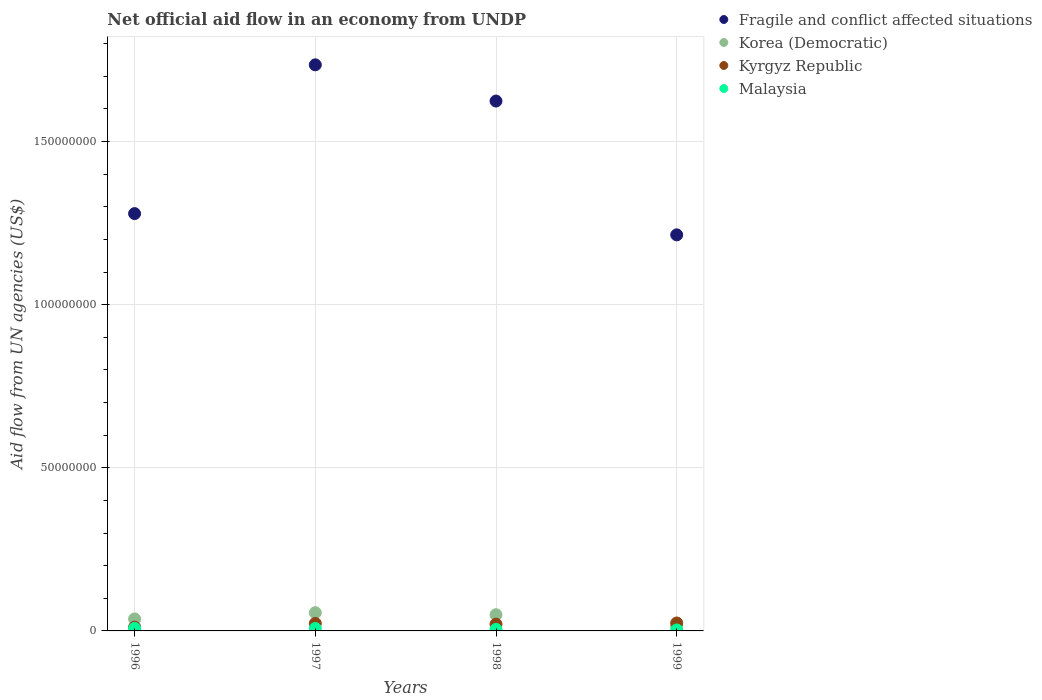How many different coloured dotlines are there?
Offer a very short reply. 4. Is the number of dotlines equal to the number of legend labels?
Make the answer very short. Yes. What is the net official aid flow in Kyrgyz Republic in 1999?
Your answer should be compact. 2.43e+06. Across all years, what is the maximum net official aid flow in Fragile and conflict affected situations?
Ensure brevity in your answer.  1.74e+08. Across all years, what is the minimum net official aid flow in Malaysia?
Provide a short and direct response. 3.00e+05. In which year was the net official aid flow in Kyrgyz Republic minimum?
Offer a terse response. 1996. What is the total net official aid flow in Korea (Democratic) in the graph?
Give a very brief answer. 1.56e+07. What is the difference between the net official aid flow in Korea (Democratic) in 1997 and that in 1998?
Give a very brief answer. 6.30e+05. What is the difference between the net official aid flow in Malaysia in 1998 and the net official aid flow in Fragile and conflict affected situations in 1996?
Offer a terse response. -1.27e+08. What is the average net official aid flow in Korea (Democratic) per year?
Your answer should be compact. 3.89e+06. In the year 1998, what is the difference between the net official aid flow in Korea (Democratic) and net official aid flow in Fragile and conflict affected situations?
Give a very brief answer. -1.57e+08. In how many years, is the net official aid flow in Kyrgyz Republic greater than 90000000 US$?
Keep it short and to the point. 0. What is the ratio of the net official aid flow in Korea (Democratic) in 1998 to that in 1999?
Ensure brevity in your answer.  3.77. What is the difference between the highest and the second highest net official aid flow in Kyrgyz Republic?
Provide a succinct answer. 1.30e+05. What is the difference between the highest and the lowest net official aid flow in Kyrgyz Republic?
Provide a succinct answer. 1.27e+06. Is the sum of the net official aid flow in Fragile and conflict affected situations in 1996 and 1998 greater than the maximum net official aid flow in Malaysia across all years?
Offer a very short reply. Yes. Is it the case that in every year, the sum of the net official aid flow in Kyrgyz Republic and net official aid flow in Fragile and conflict affected situations  is greater than the sum of net official aid flow in Malaysia and net official aid flow in Korea (Democratic)?
Your answer should be compact. No. Is it the case that in every year, the sum of the net official aid flow in Kyrgyz Republic and net official aid flow in Korea (Democratic)  is greater than the net official aid flow in Malaysia?
Keep it short and to the point. Yes. Is the net official aid flow in Fragile and conflict affected situations strictly greater than the net official aid flow in Kyrgyz Republic over the years?
Your answer should be very brief. Yes. How many dotlines are there?
Give a very brief answer. 4. Are the values on the major ticks of Y-axis written in scientific E-notation?
Offer a very short reply. No. Does the graph contain any zero values?
Offer a very short reply. No. Does the graph contain grids?
Ensure brevity in your answer.  Yes. How are the legend labels stacked?
Make the answer very short. Vertical. What is the title of the graph?
Your answer should be very brief. Net official aid flow in an economy from UNDP. What is the label or title of the Y-axis?
Provide a short and direct response. Aid flow from UN agencies (US$). What is the Aid flow from UN agencies (US$) of Fragile and conflict affected situations in 1996?
Offer a terse response. 1.28e+08. What is the Aid flow from UN agencies (US$) in Korea (Democratic) in 1996?
Provide a short and direct response. 3.68e+06. What is the Aid flow from UN agencies (US$) in Kyrgyz Republic in 1996?
Your answer should be compact. 1.16e+06. What is the Aid flow from UN agencies (US$) in Malaysia in 1996?
Ensure brevity in your answer.  7.80e+05. What is the Aid flow from UN agencies (US$) of Fragile and conflict affected situations in 1997?
Keep it short and to the point. 1.74e+08. What is the Aid flow from UN agencies (US$) in Korea (Democratic) in 1997?
Offer a terse response. 5.60e+06. What is the Aid flow from UN agencies (US$) in Kyrgyz Republic in 1997?
Keep it short and to the point. 2.30e+06. What is the Aid flow from UN agencies (US$) in Malaysia in 1997?
Give a very brief answer. 7.50e+05. What is the Aid flow from UN agencies (US$) of Fragile and conflict affected situations in 1998?
Provide a succinct answer. 1.62e+08. What is the Aid flow from UN agencies (US$) of Korea (Democratic) in 1998?
Provide a succinct answer. 4.97e+06. What is the Aid flow from UN agencies (US$) in Kyrgyz Republic in 1998?
Your answer should be compact. 2.07e+06. What is the Aid flow from UN agencies (US$) in Fragile and conflict affected situations in 1999?
Your answer should be very brief. 1.21e+08. What is the Aid flow from UN agencies (US$) in Korea (Democratic) in 1999?
Your response must be concise. 1.32e+06. What is the Aid flow from UN agencies (US$) of Kyrgyz Republic in 1999?
Keep it short and to the point. 2.43e+06. Across all years, what is the maximum Aid flow from UN agencies (US$) in Fragile and conflict affected situations?
Offer a very short reply. 1.74e+08. Across all years, what is the maximum Aid flow from UN agencies (US$) in Korea (Democratic)?
Provide a short and direct response. 5.60e+06. Across all years, what is the maximum Aid flow from UN agencies (US$) in Kyrgyz Republic?
Your answer should be very brief. 2.43e+06. Across all years, what is the maximum Aid flow from UN agencies (US$) in Malaysia?
Ensure brevity in your answer.  7.80e+05. Across all years, what is the minimum Aid flow from UN agencies (US$) in Fragile and conflict affected situations?
Give a very brief answer. 1.21e+08. Across all years, what is the minimum Aid flow from UN agencies (US$) of Korea (Democratic)?
Your answer should be compact. 1.32e+06. Across all years, what is the minimum Aid flow from UN agencies (US$) of Kyrgyz Republic?
Offer a terse response. 1.16e+06. Across all years, what is the minimum Aid flow from UN agencies (US$) in Malaysia?
Your answer should be compact. 3.00e+05. What is the total Aid flow from UN agencies (US$) in Fragile and conflict affected situations in the graph?
Keep it short and to the point. 5.85e+08. What is the total Aid flow from UN agencies (US$) in Korea (Democratic) in the graph?
Offer a very short reply. 1.56e+07. What is the total Aid flow from UN agencies (US$) in Kyrgyz Republic in the graph?
Give a very brief answer. 7.96e+06. What is the total Aid flow from UN agencies (US$) in Malaysia in the graph?
Provide a short and direct response. 2.29e+06. What is the difference between the Aid flow from UN agencies (US$) in Fragile and conflict affected situations in 1996 and that in 1997?
Give a very brief answer. -4.56e+07. What is the difference between the Aid flow from UN agencies (US$) in Korea (Democratic) in 1996 and that in 1997?
Offer a terse response. -1.92e+06. What is the difference between the Aid flow from UN agencies (US$) in Kyrgyz Republic in 1996 and that in 1997?
Provide a succinct answer. -1.14e+06. What is the difference between the Aid flow from UN agencies (US$) in Malaysia in 1996 and that in 1997?
Keep it short and to the point. 3.00e+04. What is the difference between the Aid flow from UN agencies (US$) of Fragile and conflict affected situations in 1996 and that in 1998?
Provide a short and direct response. -3.45e+07. What is the difference between the Aid flow from UN agencies (US$) in Korea (Democratic) in 1996 and that in 1998?
Ensure brevity in your answer.  -1.29e+06. What is the difference between the Aid flow from UN agencies (US$) in Kyrgyz Republic in 1996 and that in 1998?
Keep it short and to the point. -9.10e+05. What is the difference between the Aid flow from UN agencies (US$) of Fragile and conflict affected situations in 1996 and that in 1999?
Your answer should be very brief. 6.51e+06. What is the difference between the Aid flow from UN agencies (US$) in Korea (Democratic) in 1996 and that in 1999?
Provide a short and direct response. 2.36e+06. What is the difference between the Aid flow from UN agencies (US$) in Kyrgyz Republic in 1996 and that in 1999?
Your answer should be compact. -1.27e+06. What is the difference between the Aid flow from UN agencies (US$) in Fragile and conflict affected situations in 1997 and that in 1998?
Your answer should be compact. 1.11e+07. What is the difference between the Aid flow from UN agencies (US$) of Korea (Democratic) in 1997 and that in 1998?
Ensure brevity in your answer.  6.30e+05. What is the difference between the Aid flow from UN agencies (US$) in Kyrgyz Republic in 1997 and that in 1998?
Ensure brevity in your answer.  2.30e+05. What is the difference between the Aid flow from UN agencies (US$) of Malaysia in 1997 and that in 1998?
Offer a very short reply. 2.90e+05. What is the difference between the Aid flow from UN agencies (US$) in Fragile and conflict affected situations in 1997 and that in 1999?
Offer a very short reply. 5.21e+07. What is the difference between the Aid flow from UN agencies (US$) in Korea (Democratic) in 1997 and that in 1999?
Make the answer very short. 4.28e+06. What is the difference between the Aid flow from UN agencies (US$) in Kyrgyz Republic in 1997 and that in 1999?
Make the answer very short. -1.30e+05. What is the difference between the Aid flow from UN agencies (US$) in Fragile and conflict affected situations in 1998 and that in 1999?
Provide a short and direct response. 4.10e+07. What is the difference between the Aid flow from UN agencies (US$) of Korea (Democratic) in 1998 and that in 1999?
Give a very brief answer. 3.65e+06. What is the difference between the Aid flow from UN agencies (US$) in Kyrgyz Republic in 1998 and that in 1999?
Keep it short and to the point. -3.60e+05. What is the difference between the Aid flow from UN agencies (US$) in Malaysia in 1998 and that in 1999?
Your answer should be very brief. 1.60e+05. What is the difference between the Aid flow from UN agencies (US$) of Fragile and conflict affected situations in 1996 and the Aid flow from UN agencies (US$) of Korea (Democratic) in 1997?
Give a very brief answer. 1.22e+08. What is the difference between the Aid flow from UN agencies (US$) of Fragile and conflict affected situations in 1996 and the Aid flow from UN agencies (US$) of Kyrgyz Republic in 1997?
Ensure brevity in your answer.  1.26e+08. What is the difference between the Aid flow from UN agencies (US$) in Fragile and conflict affected situations in 1996 and the Aid flow from UN agencies (US$) in Malaysia in 1997?
Ensure brevity in your answer.  1.27e+08. What is the difference between the Aid flow from UN agencies (US$) of Korea (Democratic) in 1996 and the Aid flow from UN agencies (US$) of Kyrgyz Republic in 1997?
Provide a succinct answer. 1.38e+06. What is the difference between the Aid flow from UN agencies (US$) in Korea (Democratic) in 1996 and the Aid flow from UN agencies (US$) in Malaysia in 1997?
Keep it short and to the point. 2.93e+06. What is the difference between the Aid flow from UN agencies (US$) in Fragile and conflict affected situations in 1996 and the Aid flow from UN agencies (US$) in Korea (Democratic) in 1998?
Your answer should be compact. 1.23e+08. What is the difference between the Aid flow from UN agencies (US$) in Fragile and conflict affected situations in 1996 and the Aid flow from UN agencies (US$) in Kyrgyz Republic in 1998?
Provide a short and direct response. 1.26e+08. What is the difference between the Aid flow from UN agencies (US$) of Fragile and conflict affected situations in 1996 and the Aid flow from UN agencies (US$) of Malaysia in 1998?
Your answer should be very brief. 1.27e+08. What is the difference between the Aid flow from UN agencies (US$) of Korea (Democratic) in 1996 and the Aid flow from UN agencies (US$) of Kyrgyz Republic in 1998?
Provide a short and direct response. 1.61e+06. What is the difference between the Aid flow from UN agencies (US$) in Korea (Democratic) in 1996 and the Aid flow from UN agencies (US$) in Malaysia in 1998?
Provide a short and direct response. 3.22e+06. What is the difference between the Aid flow from UN agencies (US$) of Fragile and conflict affected situations in 1996 and the Aid flow from UN agencies (US$) of Korea (Democratic) in 1999?
Provide a succinct answer. 1.27e+08. What is the difference between the Aid flow from UN agencies (US$) of Fragile and conflict affected situations in 1996 and the Aid flow from UN agencies (US$) of Kyrgyz Republic in 1999?
Give a very brief answer. 1.25e+08. What is the difference between the Aid flow from UN agencies (US$) in Fragile and conflict affected situations in 1996 and the Aid flow from UN agencies (US$) in Malaysia in 1999?
Your response must be concise. 1.28e+08. What is the difference between the Aid flow from UN agencies (US$) in Korea (Democratic) in 1996 and the Aid flow from UN agencies (US$) in Kyrgyz Republic in 1999?
Provide a short and direct response. 1.25e+06. What is the difference between the Aid flow from UN agencies (US$) in Korea (Democratic) in 1996 and the Aid flow from UN agencies (US$) in Malaysia in 1999?
Your response must be concise. 3.38e+06. What is the difference between the Aid flow from UN agencies (US$) of Kyrgyz Republic in 1996 and the Aid flow from UN agencies (US$) of Malaysia in 1999?
Ensure brevity in your answer.  8.60e+05. What is the difference between the Aid flow from UN agencies (US$) of Fragile and conflict affected situations in 1997 and the Aid flow from UN agencies (US$) of Korea (Democratic) in 1998?
Ensure brevity in your answer.  1.69e+08. What is the difference between the Aid flow from UN agencies (US$) in Fragile and conflict affected situations in 1997 and the Aid flow from UN agencies (US$) in Kyrgyz Republic in 1998?
Your response must be concise. 1.71e+08. What is the difference between the Aid flow from UN agencies (US$) in Fragile and conflict affected situations in 1997 and the Aid flow from UN agencies (US$) in Malaysia in 1998?
Keep it short and to the point. 1.73e+08. What is the difference between the Aid flow from UN agencies (US$) in Korea (Democratic) in 1997 and the Aid flow from UN agencies (US$) in Kyrgyz Republic in 1998?
Provide a succinct answer. 3.53e+06. What is the difference between the Aid flow from UN agencies (US$) in Korea (Democratic) in 1997 and the Aid flow from UN agencies (US$) in Malaysia in 1998?
Make the answer very short. 5.14e+06. What is the difference between the Aid flow from UN agencies (US$) in Kyrgyz Republic in 1997 and the Aid flow from UN agencies (US$) in Malaysia in 1998?
Offer a terse response. 1.84e+06. What is the difference between the Aid flow from UN agencies (US$) of Fragile and conflict affected situations in 1997 and the Aid flow from UN agencies (US$) of Korea (Democratic) in 1999?
Make the answer very short. 1.72e+08. What is the difference between the Aid flow from UN agencies (US$) of Fragile and conflict affected situations in 1997 and the Aid flow from UN agencies (US$) of Kyrgyz Republic in 1999?
Provide a short and direct response. 1.71e+08. What is the difference between the Aid flow from UN agencies (US$) of Fragile and conflict affected situations in 1997 and the Aid flow from UN agencies (US$) of Malaysia in 1999?
Give a very brief answer. 1.73e+08. What is the difference between the Aid flow from UN agencies (US$) in Korea (Democratic) in 1997 and the Aid flow from UN agencies (US$) in Kyrgyz Republic in 1999?
Provide a short and direct response. 3.17e+06. What is the difference between the Aid flow from UN agencies (US$) of Korea (Democratic) in 1997 and the Aid flow from UN agencies (US$) of Malaysia in 1999?
Keep it short and to the point. 5.30e+06. What is the difference between the Aid flow from UN agencies (US$) in Kyrgyz Republic in 1997 and the Aid flow from UN agencies (US$) in Malaysia in 1999?
Give a very brief answer. 2.00e+06. What is the difference between the Aid flow from UN agencies (US$) of Fragile and conflict affected situations in 1998 and the Aid flow from UN agencies (US$) of Korea (Democratic) in 1999?
Ensure brevity in your answer.  1.61e+08. What is the difference between the Aid flow from UN agencies (US$) in Fragile and conflict affected situations in 1998 and the Aid flow from UN agencies (US$) in Kyrgyz Republic in 1999?
Offer a terse response. 1.60e+08. What is the difference between the Aid flow from UN agencies (US$) in Fragile and conflict affected situations in 1998 and the Aid flow from UN agencies (US$) in Malaysia in 1999?
Make the answer very short. 1.62e+08. What is the difference between the Aid flow from UN agencies (US$) of Korea (Democratic) in 1998 and the Aid flow from UN agencies (US$) of Kyrgyz Republic in 1999?
Your answer should be very brief. 2.54e+06. What is the difference between the Aid flow from UN agencies (US$) in Korea (Democratic) in 1998 and the Aid flow from UN agencies (US$) in Malaysia in 1999?
Offer a terse response. 4.67e+06. What is the difference between the Aid flow from UN agencies (US$) in Kyrgyz Republic in 1998 and the Aid flow from UN agencies (US$) in Malaysia in 1999?
Ensure brevity in your answer.  1.77e+06. What is the average Aid flow from UN agencies (US$) in Fragile and conflict affected situations per year?
Provide a succinct answer. 1.46e+08. What is the average Aid flow from UN agencies (US$) of Korea (Democratic) per year?
Ensure brevity in your answer.  3.89e+06. What is the average Aid flow from UN agencies (US$) of Kyrgyz Republic per year?
Your response must be concise. 1.99e+06. What is the average Aid flow from UN agencies (US$) in Malaysia per year?
Offer a very short reply. 5.72e+05. In the year 1996, what is the difference between the Aid flow from UN agencies (US$) in Fragile and conflict affected situations and Aid flow from UN agencies (US$) in Korea (Democratic)?
Ensure brevity in your answer.  1.24e+08. In the year 1996, what is the difference between the Aid flow from UN agencies (US$) in Fragile and conflict affected situations and Aid flow from UN agencies (US$) in Kyrgyz Republic?
Your answer should be compact. 1.27e+08. In the year 1996, what is the difference between the Aid flow from UN agencies (US$) of Fragile and conflict affected situations and Aid flow from UN agencies (US$) of Malaysia?
Your answer should be very brief. 1.27e+08. In the year 1996, what is the difference between the Aid flow from UN agencies (US$) in Korea (Democratic) and Aid flow from UN agencies (US$) in Kyrgyz Republic?
Provide a succinct answer. 2.52e+06. In the year 1996, what is the difference between the Aid flow from UN agencies (US$) in Korea (Democratic) and Aid flow from UN agencies (US$) in Malaysia?
Keep it short and to the point. 2.90e+06. In the year 1996, what is the difference between the Aid flow from UN agencies (US$) in Kyrgyz Republic and Aid flow from UN agencies (US$) in Malaysia?
Your answer should be compact. 3.80e+05. In the year 1997, what is the difference between the Aid flow from UN agencies (US$) in Fragile and conflict affected situations and Aid flow from UN agencies (US$) in Korea (Democratic)?
Make the answer very short. 1.68e+08. In the year 1997, what is the difference between the Aid flow from UN agencies (US$) of Fragile and conflict affected situations and Aid flow from UN agencies (US$) of Kyrgyz Republic?
Give a very brief answer. 1.71e+08. In the year 1997, what is the difference between the Aid flow from UN agencies (US$) of Fragile and conflict affected situations and Aid flow from UN agencies (US$) of Malaysia?
Your answer should be very brief. 1.73e+08. In the year 1997, what is the difference between the Aid flow from UN agencies (US$) in Korea (Democratic) and Aid flow from UN agencies (US$) in Kyrgyz Republic?
Provide a succinct answer. 3.30e+06. In the year 1997, what is the difference between the Aid flow from UN agencies (US$) in Korea (Democratic) and Aid flow from UN agencies (US$) in Malaysia?
Your answer should be very brief. 4.85e+06. In the year 1997, what is the difference between the Aid flow from UN agencies (US$) of Kyrgyz Republic and Aid flow from UN agencies (US$) of Malaysia?
Ensure brevity in your answer.  1.55e+06. In the year 1998, what is the difference between the Aid flow from UN agencies (US$) in Fragile and conflict affected situations and Aid flow from UN agencies (US$) in Korea (Democratic)?
Offer a very short reply. 1.57e+08. In the year 1998, what is the difference between the Aid flow from UN agencies (US$) in Fragile and conflict affected situations and Aid flow from UN agencies (US$) in Kyrgyz Republic?
Keep it short and to the point. 1.60e+08. In the year 1998, what is the difference between the Aid flow from UN agencies (US$) of Fragile and conflict affected situations and Aid flow from UN agencies (US$) of Malaysia?
Provide a succinct answer. 1.62e+08. In the year 1998, what is the difference between the Aid flow from UN agencies (US$) in Korea (Democratic) and Aid flow from UN agencies (US$) in Kyrgyz Republic?
Provide a short and direct response. 2.90e+06. In the year 1998, what is the difference between the Aid flow from UN agencies (US$) in Korea (Democratic) and Aid flow from UN agencies (US$) in Malaysia?
Keep it short and to the point. 4.51e+06. In the year 1998, what is the difference between the Aid flow from UN agencies (US$) of Kyrgyz Republic and Aid flow from UN agencies (US$) of Malaysia?
Your answer should be very brief. 1.61e+06. In the year 1999, what is the difference between the Aid flow from UN agencies (US$) of Fragile and conflict affected situations and Aid flow from UN agencies (US$) of Korea (Democratic)?
Keep it short and to the point. 1.20e+08. In the year 1999, what is the difference between the Aid flow from UN agencies (US$) in Fragile and conflict affected situations and Aid flow from UN agencies (US$) in Kyrgyz Republic?
Ensure brevity in your answer.  1.19e+08. In the year 1999, what is the difference between the Aid flow from UN agencies (US$) of Fragile and conflict affected situations and Aid flow from UN agencies (US$) of Malaysia?
Offer a very short reply. 1.21e+08. In the year 1999, what is the difference between the Aid flow from UN agencies (US$) of Korea (Democratic) and Aid flow from UN agencies (US$) of Kyrgyz Republic?
Your answer should be compact. -1.11e+06. In the year 1999, what is the difference between the Aid flow from UN agencies (US$) of Korea (Democratic) and Aid flow from UN agencies (US$) of Malaysia?
Offer a terse response. 1.02e+06. In the year 1999, what is the difference between the Aid flow from UN agencies (US$) of Kyrgyz Republic and Aid flow from UN agencies (US$) of Malaysia?
Make the answer very short. 2.13e+06. What is the ratio of the Aid flow from UN agencies (US$) of Fragile and conflict affected situations in 1996 to that in 1997?
Provide a succinct answer. 0.74. What is the ratio of the Aid flow from UN agencies (US$) in Korea (Democratic) in 1996 to that in 1997?
Provide a succinct answer. 0.66. What is the ratio of the Aid flow from UN agencies (US$) in Kyrgyz Republic in 1996 to that in 1997?
Give a very brief answer. 0.5. What is the ratio of the Aid flow from UN agencies (US$) in Fragile and conflict affected situations in 1996 to that in 1998?
Provide a short and direct response. 0.79. What is the ratio of the Aid flow from UN agencies (US$) in Korea (Democratic) in 1996 to that in 1998?
Keep it short and to the point. 0.74. What is the ratio of the Aid flow from UN agencies (US$) of Kyrgyz Republic in 1996 to that in 1998?
Provide a succinct answer. 0.56. What is the ratio of the Aid flow from UN agencies (US$) of Malaysia in 1996 to that in 1998?
Keep it short and to the point. 1.7. What is the ratio of the Aid flow from UN agencies (US$) of Fragile and conflict affected situations in 1996 to that in 1999?
Your response must be concise. 1.05. What is the ratio of the Aid flow from UN agencies (US$) in Korea (Democratic) in 1996 to that in 1999?
Provide a succinct answer. 2.79. What is the ratio of the Aid flow from UN agencies (US$) of Kyrgyz Republic in 1996 to that in 1999?
Offer a very short reply. 0.48. What is the ratio of the Aid flow from UN agencies (US$) of Malaysia in 1996 to that in 1999?
Your response must be concise. 2.6. What is the ratio of the Aid flow from UN agencies (US$) in Fragile and conflict affected situations in 1997 to that in 1998?
Provide a short and direct response. 1.07. What is the ratio of the Aid flow from UN agencies (US$) of Korea (Democratic) in 1997 to that in 1998?
Offer a terse response. 1.13. What is the ratio of the Aid flow from UN agencies (US$) in Malaysia in 1997 to that in 1998?
Ensure brevity in your answer.  1.63. What is the ratio of the Aid flow from UN agencies (US$) in Fragile and conflict affected situations in 1997 to that in 1999?
Your answer should be very brief. 1.43. What is the ratio of the Aid flow from UN agencies (US$) of Korea (Democratic) in 1997 to that in 1999?
Your response must be concise. 4.24. What is the ratio of the Aid flow from UN agencies (US$) of Kyrgyz Republic in 1997 to that in 1999?
Ensure brevity in your answer.  0.95. What is the ratio of the Aid flow from UN agencies (US$) in Malaysia in 1997 to that in 1999?
Make the answer very short. 2.5. What is the ratio of the Aid flow from UN agencies (US$) in Fragile and conflict affected situations in 1998 to that in 1999?
Offer a terse response. 1.34. What is the ratio of the Aid flow from UN agencies (US$) of Korea (Democratic) in 1998 to that in 1999?
Offer a terse response. 3.77. What is the ratio of the Aid flow from UN agencies (US$) of Kyrgyz Republic in 1998 to that in 1999?
Your response must be concise. 0.85. What is the ratio of the Aid flow from UN agencies (US$) in Malaysia in 1998 to that in 1999?
Ensure brevity in your answer.  1.53. What is the difference between the highest and the second highest Aid flow from UN agencies (US$) of Fragile and conflict affected situations?
Your answer should be compact. 1.11e+07. What is the difference between the highest and the second highest Aid flow from UN agencies (US$) in Korea (Democratic)?
Offer a very short reply. 6.30e+05. What is the difference between the highest and the second highest Aid flow from UN agencies (US$) of Kyrgyz Republic?
Offer a very short reply. 1.30e+05. What is the difference between the highest and the lowest Aid flow from UN agencies (US$) of Fragile and conflict affected situations?
Offer a very short reply. 5.21e+07. What is the difference between the highest and the lowest Aid flow from UN agencies (US$) of Korea (Democratic)?
Ensure brevity in your answer.  4.28e+06. What is the difference between the highest and the lowest Aid flow from UN agencies (US$) of Kyrgyz Republic?
Keep it short and to the point. 1.27e+06. 